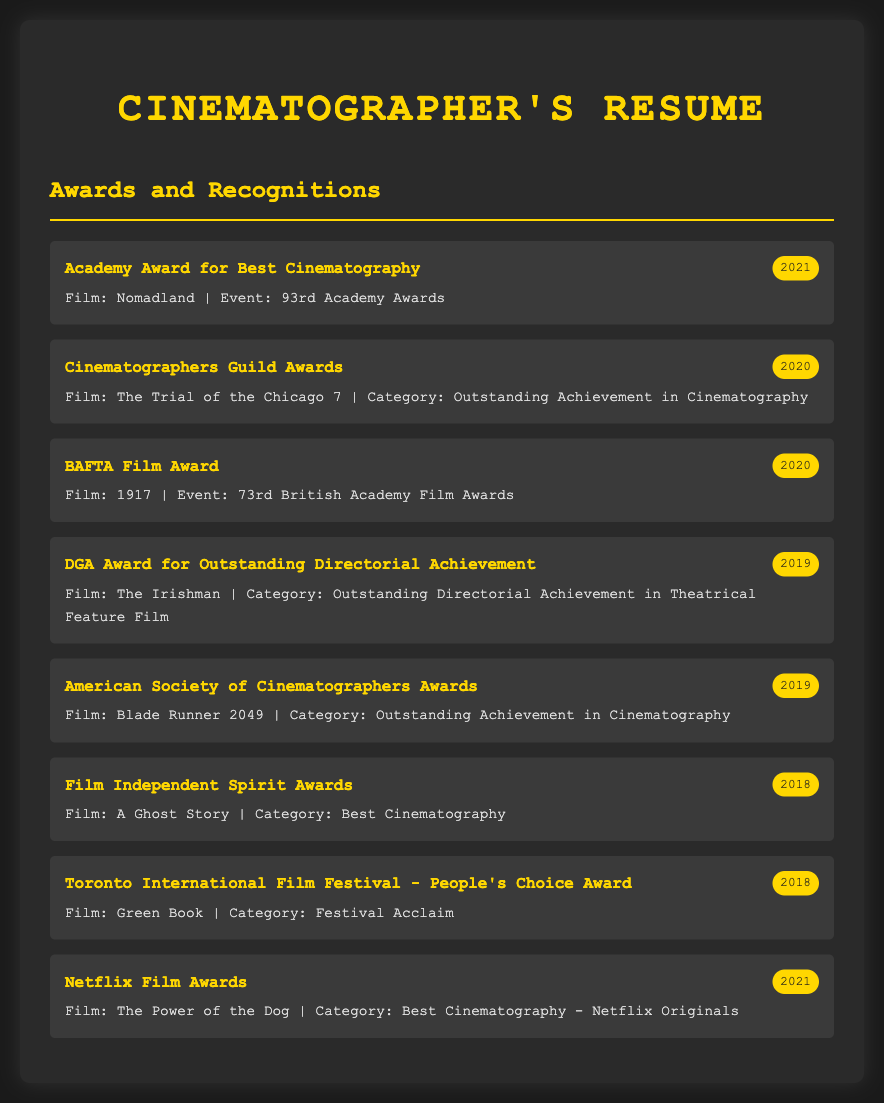What award did you win in 2021? The award won in 2021 is the Academy Award for Best Cinematography for the film Nomadland at the 93rd Academy Awards.
Answer: Academy Award for Best Cinematography Which film received a BAFTA Film Award in 2020? The film that received a BAFTA Film Award in 2020 is 1917 at the 73rd British Academy Film Awards.
Answer: 1917 What is the category of recognition for the film Blade Runner 2049? The category of recognition for Blade Runner 2049 in 2019 is Outstanding Achievement in Cinematography at the American Society of Cinematographers Awards.
Answer: Outstanding Achievement in Cinematography How many awards were received in 2018? There were two awards received in 2018, one for A Ghost Story and another for Green Book.
Answer: 2 Which event honored the film The Power of the Dog in 2021? The Netflix Film Awards honored the film The Power of the Dog in 2021, specifically for Best Cinematography - Netflix Originals.
Answer: Netflix Film Awards Which award was given for The Trial of the Chicago 7? The award given for The Trial of the Chicago 7 in 2020 is for Outstanding Achievement in Cinematography at the Cinematographers Guild Awards.
Answer: Outstanding Achievement in Cinematography What film was recognized at the Toronto International Film Festival in 2018? The film recognized at the Toronto International Film Festival in 2018 is Green Book for the People's Choice Award.
Answer: Green Book What is the event associated with the film The Irishman in 2019? The event associated with The Irishman in 2019 is the DGA Award for Outstanding Directorial Achievement.
Answer: DGA Award for Outstanding Directorial Achievement 